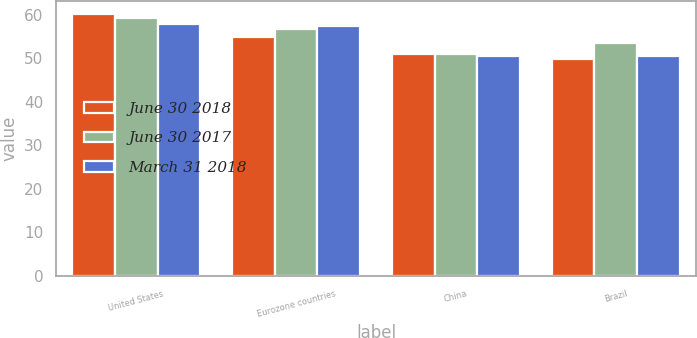Convert chart. <chart><loc_0><loc_0><loc_500><loc_500><stacked_bar_chart><ecel><fcel>United States<fcel>Eurozone countries<fcel>China<fcel>Brazil<nl><fcel>June 30 2018<fcel>60.2<fcel>54.9<fcel>51<fcel>49.8<nl><fcel>June 30 2017<fcel>59.3<fcel>56.6<fcel>51<fcel>53.4<nl><fcel>March 31 2018<fcel>57.8<fcel>57.4<fcel>50.4<fcel>50.5<nl></chart> 